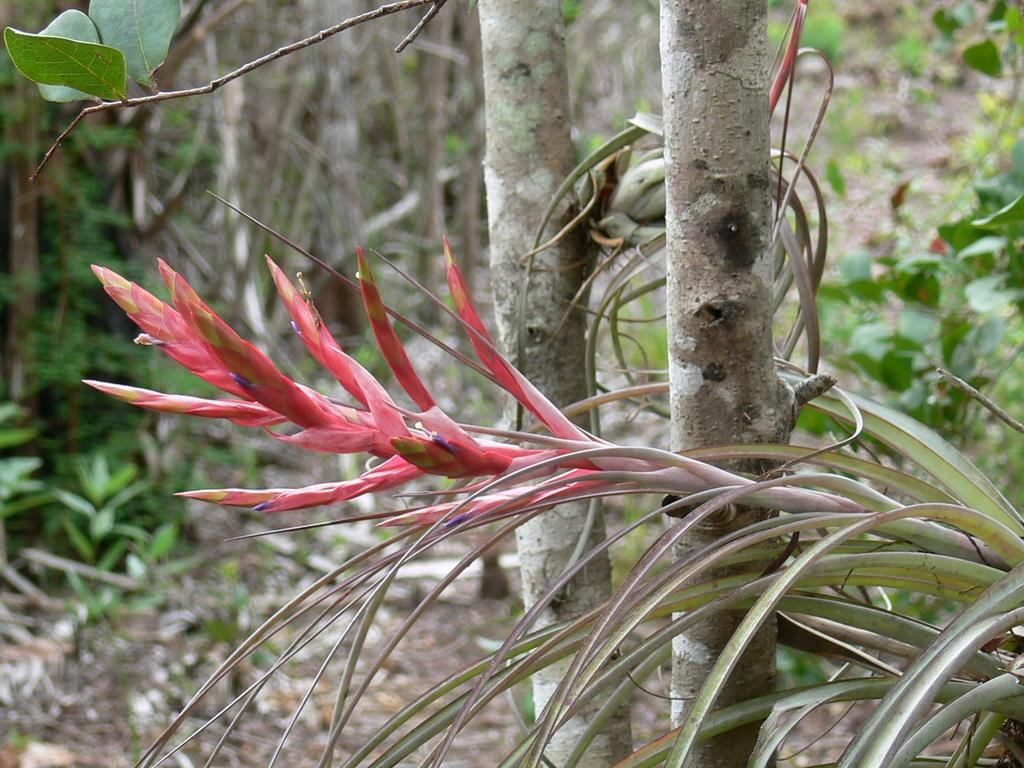What type of flowers can be seen on the plant in the image? There are red color flowers on a plant in the image. What else can be seen in the background of the image? There are plants and grass in the background of the image. Can you describe the leaves in the top left corner of the image? There are leaves on a branch in the top left corner of the image. Who is wearing a crown in the image? There is no person wearing a crown in the image. What type of game is being played in the image? There is no game being played in the image. 